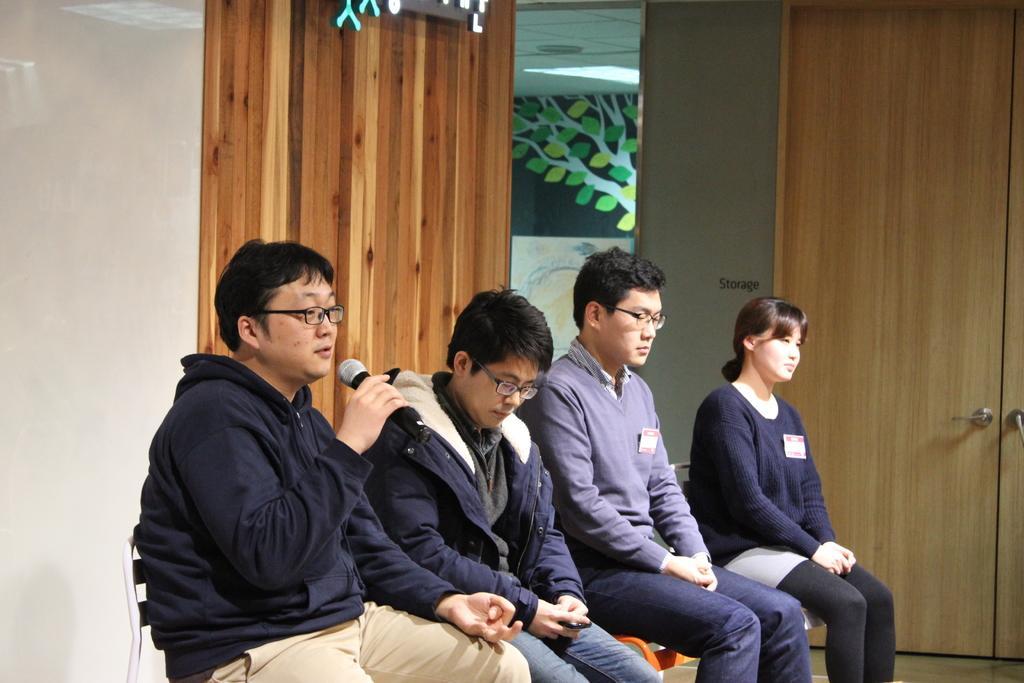Can you describe this image briefly? In the foreground of the picture we can see four persons sitting on chair. In the middle we can see pillar, door, and other objects. In the background we can see wall and a design of a tree may be on a glass. 